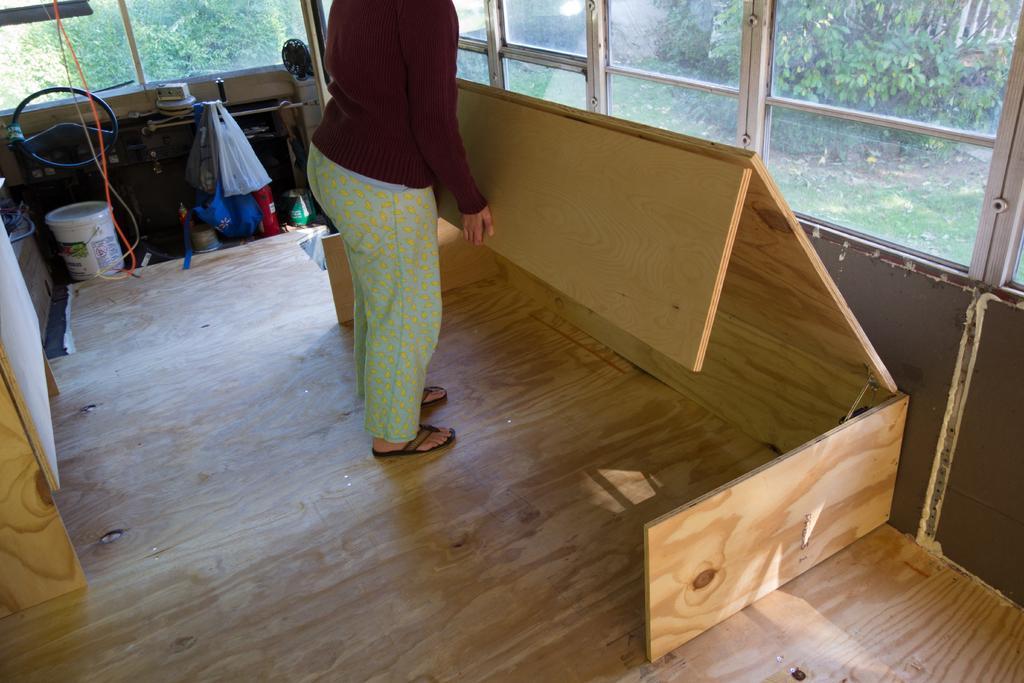Can you describe this image briefly? In this picture we can see a person standing, on the right side there is wood, we can see a bucket here, on the left side there is steering, we can see plastic bags here, in the background there is glass, from the glass we can see trees. 